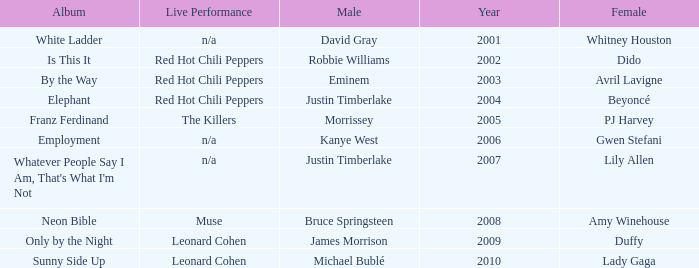Who is the male partner for amy winehouse? Bruce Springsteen. 